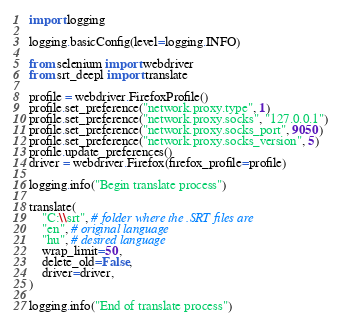<code> <loc_0><loc_0><loc_500><loc_500><_Python_>import logging

logging.basicConfig(level=logging.INFO)

from selenium import webdriver
from srt_deepl import translate

profile = webdriver.FirefoxProfile()
profile.set_preference("network.proxy.type", 1)
profile.set_preference("network.proxy.socks", "127.0.0.1")
profile.set_preference("network.proxy.socks_port", 9050)
profile.set_preference("network.proxy.socks_version", 5)
profile.update_preferences()
driver = webdriver.Firefox(firefox_profile=profile)

logging.info("Begin translate process")

translate(
    "C:\\srt", # folder where the .SRT files are
    "en", # original language
    "hu", # desired language
    wrap_limit=50,
    delete_old=False,
    driver=driver,
)

logging.info("End of translate process")
</code> 